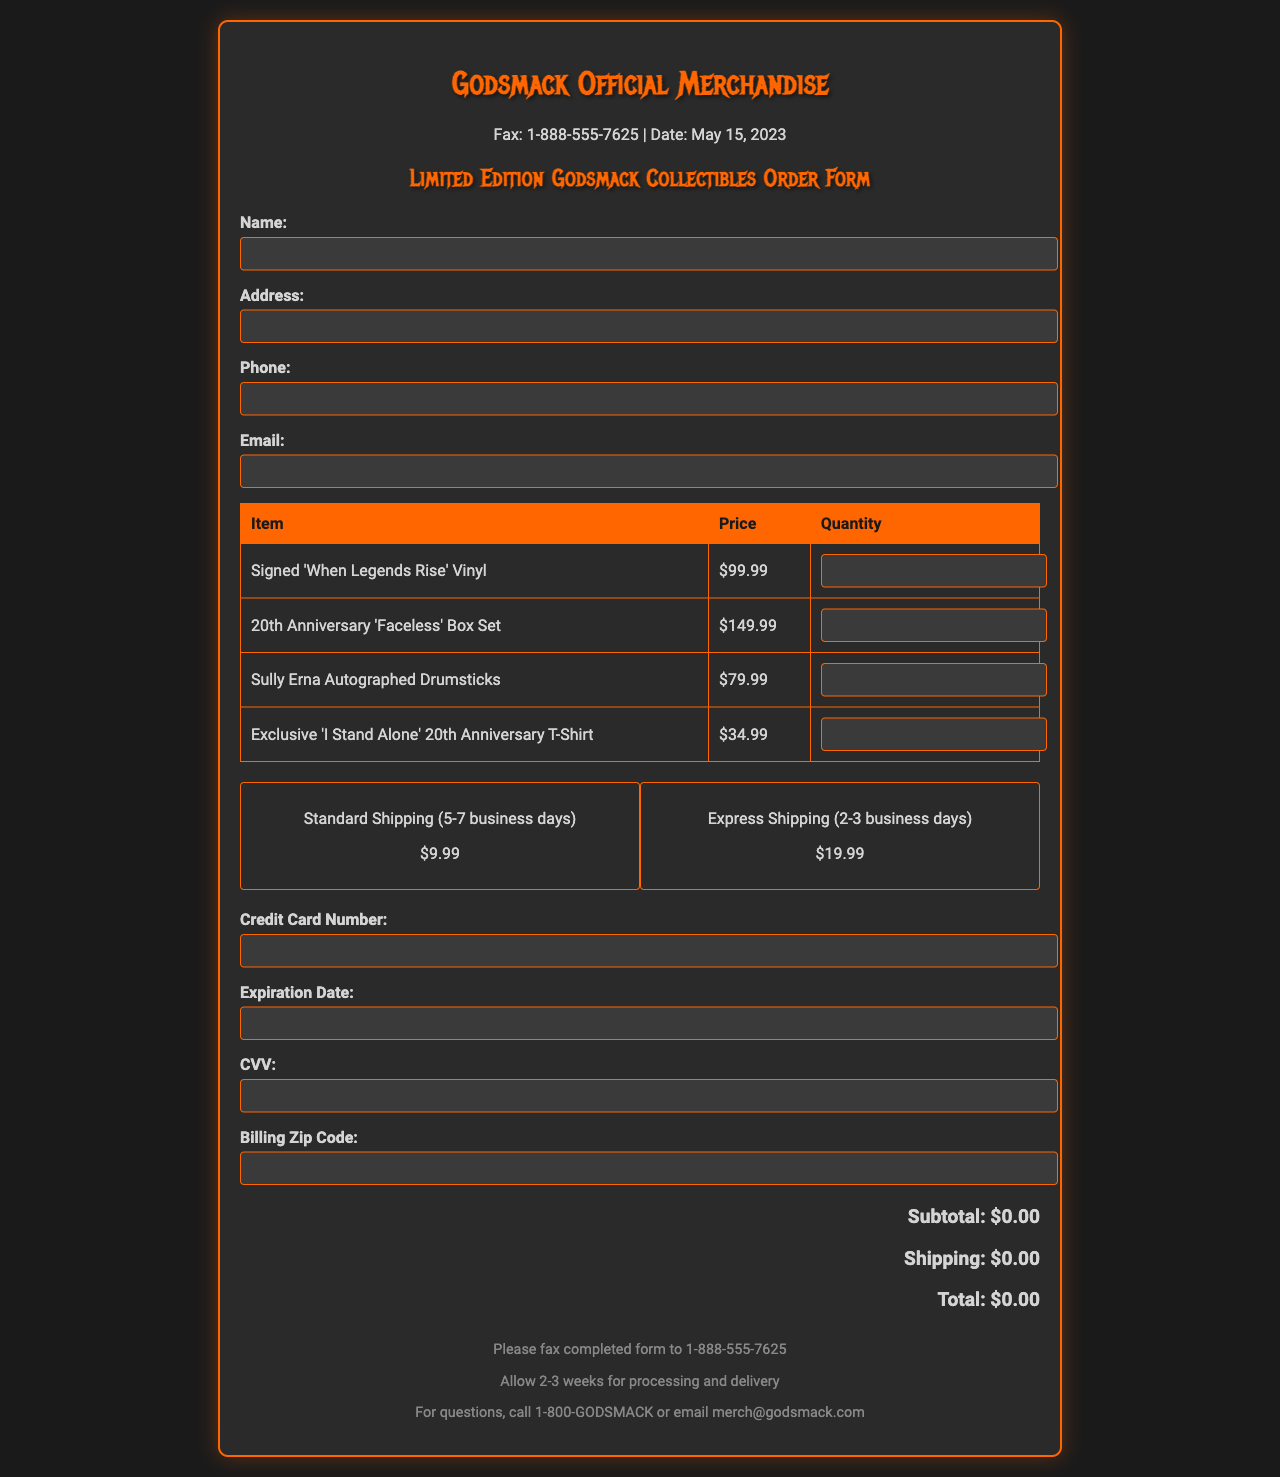What is the price of the Signed 'When Legends Rise' Vinyl? The price for the Signed 'When Legends Rise' Vinyl is listed in the document as $99.99.
Answer: $99.99 What is the total shipping cost for Standard Shipping? The document specifies that Standard Shipping costs $9.99.
Answer: $9.99 What is the expiration date field for? The expiration date field is meant to provide the due date for the credit card being used for the transaction.
Answer: Credit Card Expiration Date How long should you expect to wait for processing and delivery? The document indicates that you should allow 2-3 weeks for processing and delivery after faxing the form.
Answer: 2-3 weeks What merchandise item costs the most? The 20th Anniversary 'Faceless' Box Set is the highest priced item listed at $149.99.
Answer: $149.99 What is the total of the subtotal shown in the order form? The subtotal is displayed initially as $0.00 until items are inputted, so the answer at that stage is $0.00.
Answer: $0.00 How can you contact Godsmack for any questions? You can call 1-800-GODSMACK or email merch@godsmack.com for questions as stated in the document.
Answer: 1-800-GODSMACK What is required to complete the order form? The order form requires the user's name, address, phone, email, credit card number, expiration date, CVV, and billing zip code.
Answer: Personal and Payment Information 